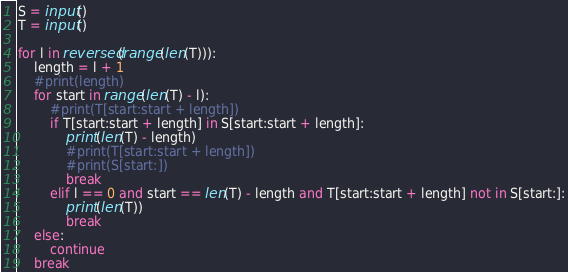Convert code to text. <code><loc_0><loc_0><loc_500><loc_500><_Python_>S = input()
T = input()

for l in reversed(range(len(T))):
    length = l + 1
    #print(length)
    for start in range(len(T) - l):
        #print(T[start:start + length])
        if T[start:start + length] in S[start:start + length]:
            print(len(T) - length)
            #print(T[start:start + length])
            #print(S[start:])
            break
        elif l == 0 and start == len(T) - length and T[start:start + length] not in S[start:]:
            print(len(T))
            break
    else:
        continue
    break</code> 